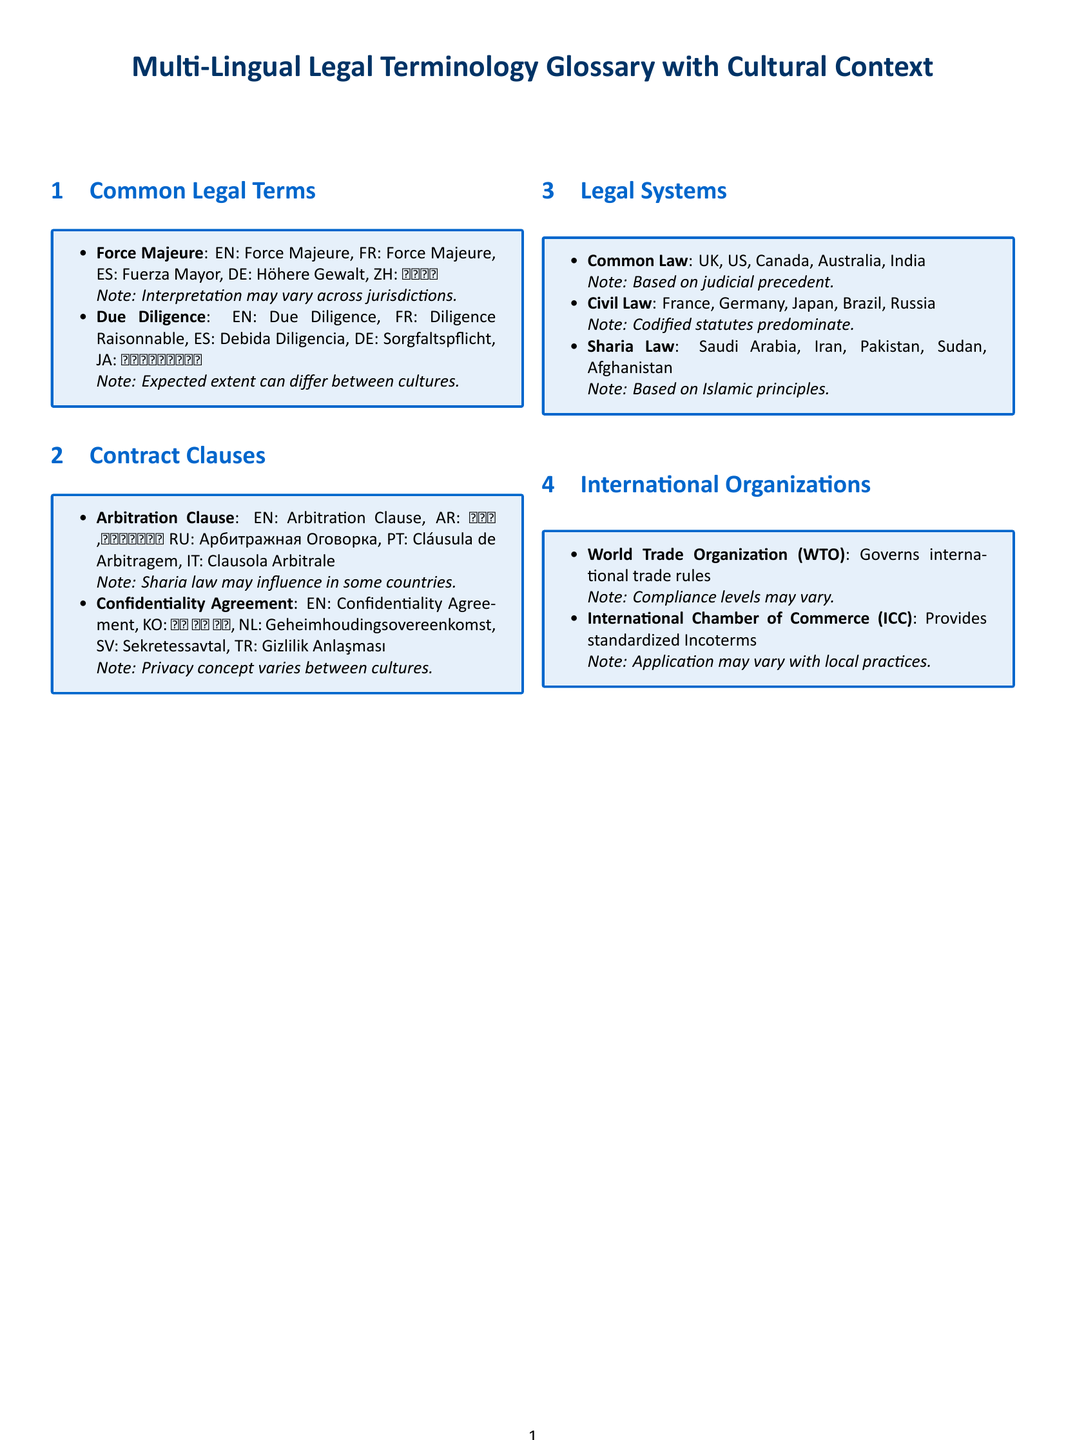What is the title of the document? The title is presented at the top of the document and states the focus on legal terminology with cultural context.
Answer: Multi-Lingual Legal Terminology Glossary with Cultural Context How many sections are in the document? The document contains multiple sections that include various legal topics.
Answer: Four What is “Force Majeure” in Spanish? The document provides the translations of legal terms in multiple languages.
Answer: Fuerza Mayor Which legal system is based on codified statutes? The document classifies legal systems and explains their basis.
Answer: Civil Law What note is associated with the Arbitration Clause? The document includes specific cultural notes alongside legal terms and clauses.
Answer: Sharia law may influence in some countries What does WTO stand for? The glossary includes acronyms related to international organizations for legal terminology.
Answer: World Trade Organization What is a key concept that varies between cultures regarding confidentiality? The document addresses cultural context in legal agreements.
Answer: Privacy concept What language is “Confidentiality Agreement” translated into Korean? The document includes translations of key legal terms in various languages including Korean.
Answer: 비밀 유지 계약 